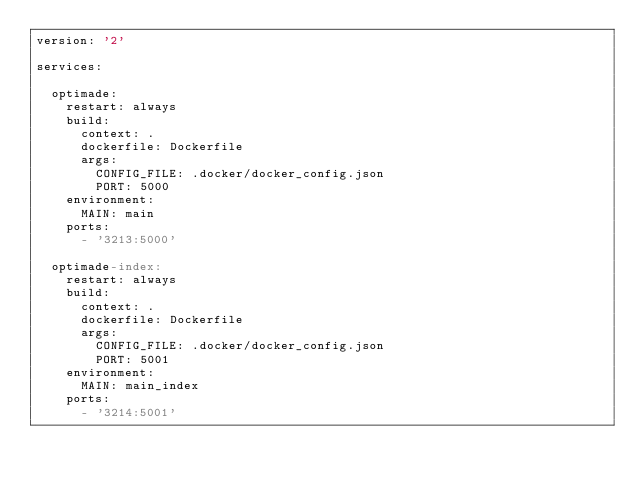Convert code to text. <code><loc_0><loc_0><loc_500><loc_500><_YAML_>version: '2'

services:

  optimade:
    restart: always
    build:
      context: .
      dockerfile: Dockerfile
      args:
        CONFIG_FILE: .docker/docker_config.json
        PORT: 5000
    environment:
      MAIN: main
    ports:
      - '3213:5000'

  optimade-index:
    restart: always
    build:
      context: .
      dockerfile: Dockerfile
      args:
        CONFIG_FILE: .docker/docker_config.json
        PORT: 5001
    environment:
      MAIN: main_index
    ports:
      - '3214:5001'
</code> 